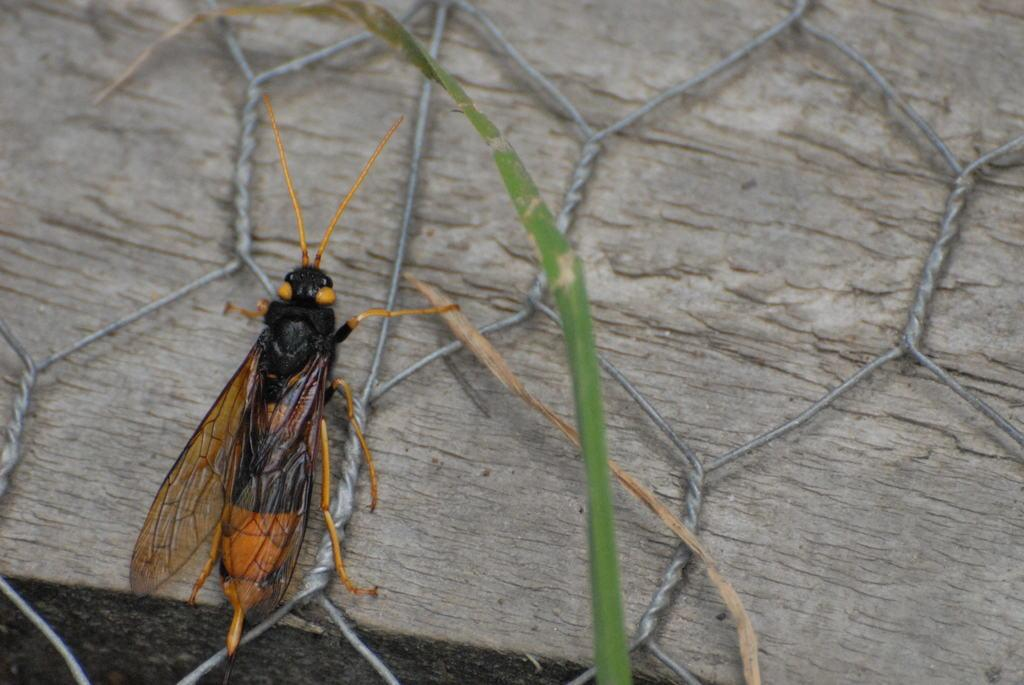What type of insect is present in the image? There is a brown cockroach in the image. What is the cockroach doing in the image? The cockroach is moving on a piece of wood. What type of drug is the cockroach carrying in the image? There is no drug present in the image; it is a brown cockroach moving on a piece of wood. What class of insect is the cockroach in the image? The provided facts do not specify the class of the cockroach; it is simply described as a brown cockroach. 